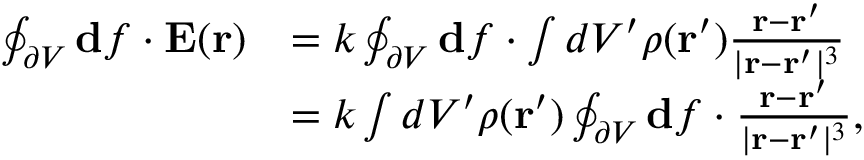<formula> <loc_0><loc_0><loc_500><loc_500>\begin{array} { r l } { \oint _ { \partial V } d f \cdot E ( r ) } & { = k \oint _ { \partial V } d f \cdot \int d V ^ { \prime } \rho ( r ^ { \prime } ) \frac { r - r ^ { \prime } } { | r - r ^ { \prime } | ^ { 3 } } } \\ & { = k \int d V ^ { \prime } \rho ( r ^ { \prime } ) \oint _ { \partial V } d f \cdot \frac { r - r ^ { \prime } } { | r - r ^ { \prime } | ^ { 3 } } , } \end{array}</formula> 